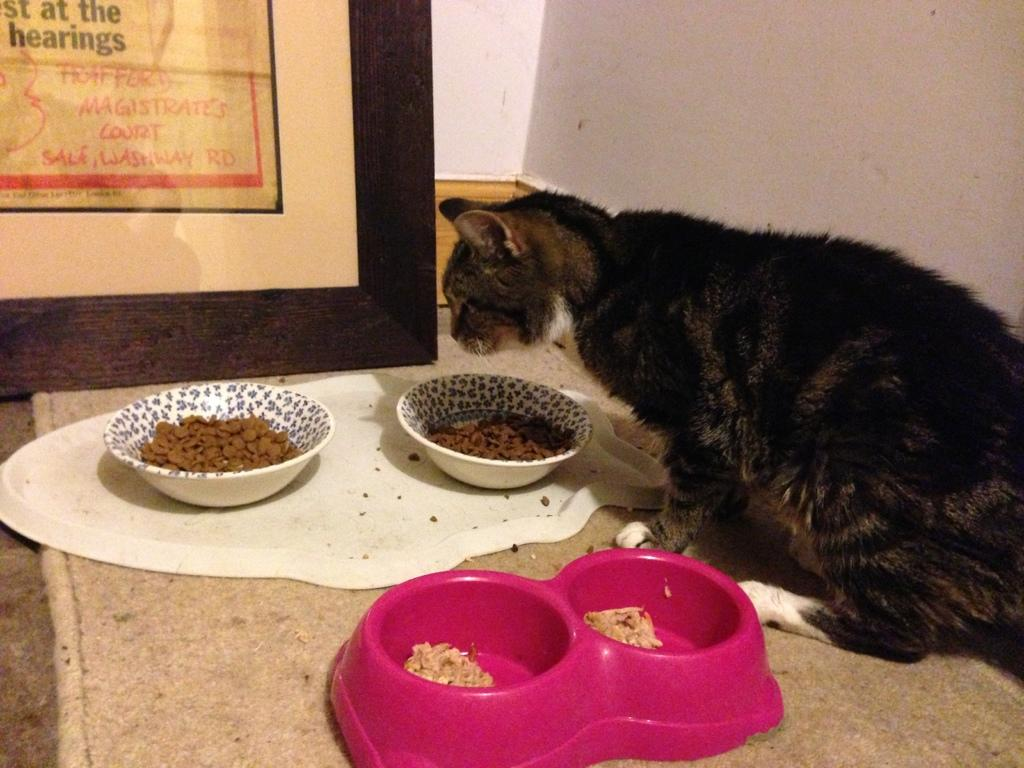What type of animal is present in the image? There is a cat in the image. What can be seen on the ground in the image? There are food items in containers on the ground. What is located beneath the cat in the image? There is a mat in the image. What is written or displayed in the image? There is a frame with text in the image. What type of background is visible in the image? There is a wall visible in the image. What type of discussion is taking place between the women in the image? There are no women present in the image, so no discussion can be observed. Can you describe the squirrel's behavior in the image? There is no squirrel present in the image. 